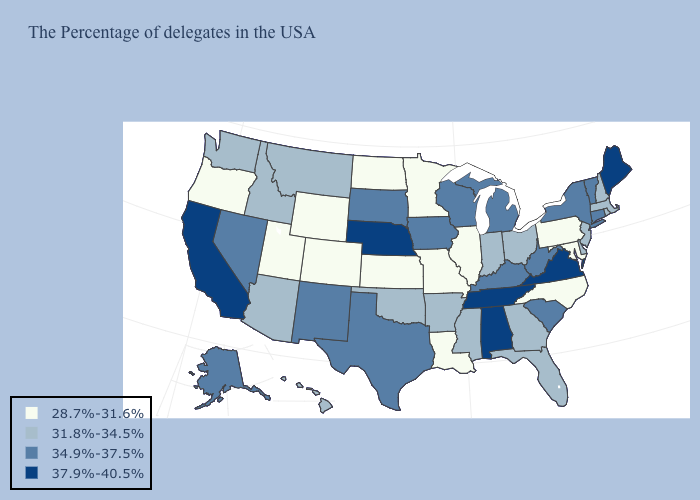Name the states that have a value in the range 34.9%-37.5%?
Concise answer only. Vermont, Connecticut, New York, South Carolina, West Virginia, Michigan, Kentucky, Wisconsin, Iowa, Texas, South Dakota, New Mexico, Nevada, Alaska. What is the value of Oregon?
Be succinct. 28.7%-31.6%. Among the states that border Connecticut , which have the lowest value?
Answer briefly. Massachusetts, Rhode Island. Name the states that have a value in the range 28.7%-31.6%?
Concise answer only. Maryland, Pennsylvania, North Carolina, Illinois, Louisiana, Missouri, Minnesota, Kansas, North Dakota, Wyoming, Colorado, Utah, Oregon. Which states have the highest value in the USA?
Be succinct. Maine, Virginia, Alabama, Tennessee, Nebraska, California. Among the states that border North Carolina , which have the lowest value?
Short answer required. Georgia. Which states have the lowest value in the South?
Answer briefly. Maryland, North Carolina, Louisiana. What is the value of Massachusetts?
Answer briefly. 31.8%-34.5%. What is the lowest value in the USA?
Answer briefly. 28.7%-31.6%. How many symbols are there in the legend?
Concise answer only. 4. Among the states that border Michigan , which have the highest value?
Keep it brief. Wisconsin. Name the states that have a value in the range 31.8%-34.5%?
Short answer required. Massachusetts, Rhode Island, New Hampshire, New Jersey, Delaware, Ohio, Florida, Georgia, Indiana, Mississippi, Arkansas, Oklahoma, Montana, Arizona, Idaho, Washington, Hawaii. What is the value of New Jersey?
Write a very short answer. 31.8%-34.5%. Which states have the lowest value in the USA?
Answer briefly. Maryland, Pennsylvania, North Carolina, Illinois, Louisiana, Missouri, Minnesota, Kansas, North Dakota, Wyoming, Colorado, Utah, Oregon. Does the first symbol in the legend represent the smallest category?
Short answer required. Yes. 